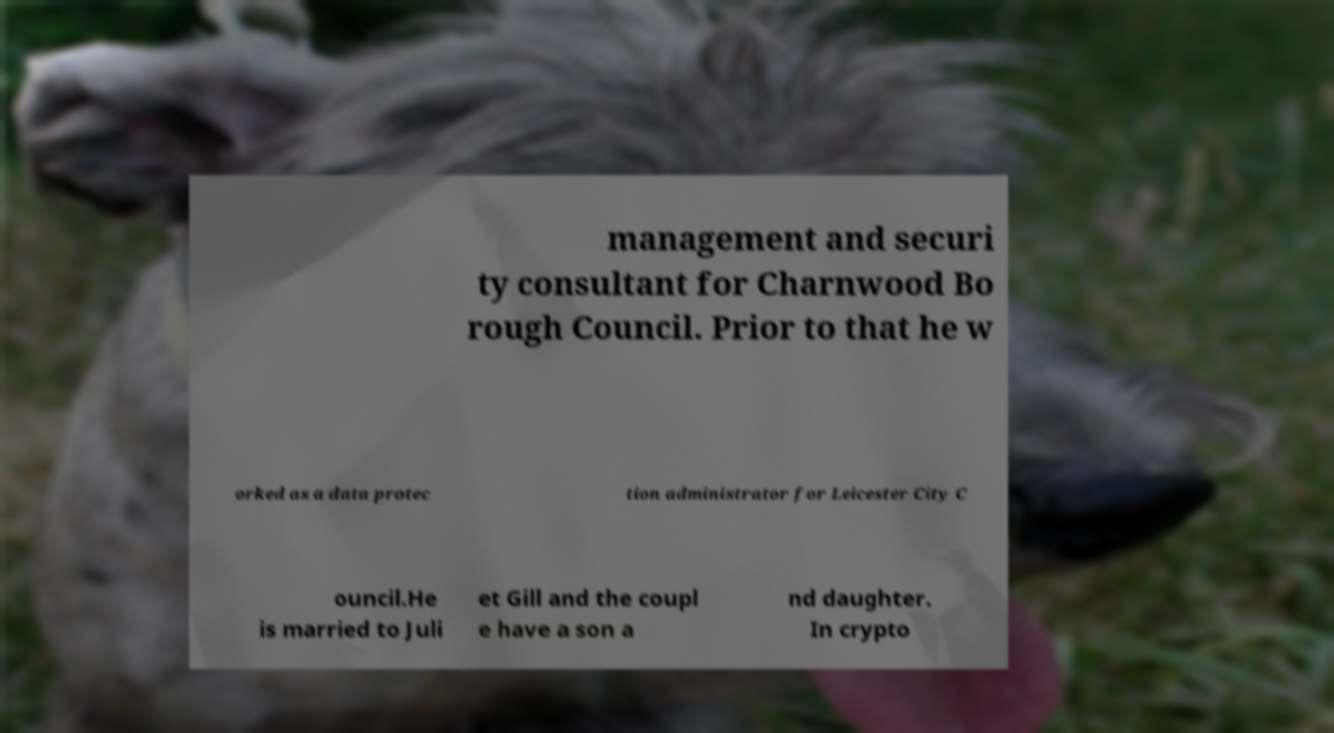Can you read and provide the text displayed in the image?This photo seems to have some interesting text. Can you extract and type it out for me? management and securi ty consultant for Charnwood Bo rough Council. Prior to that he w orked as a data protec tion administrator for Leicester City C ouncil.He is married to Juli et Gill and the coupl e have a son a nd daughter. In crypto 